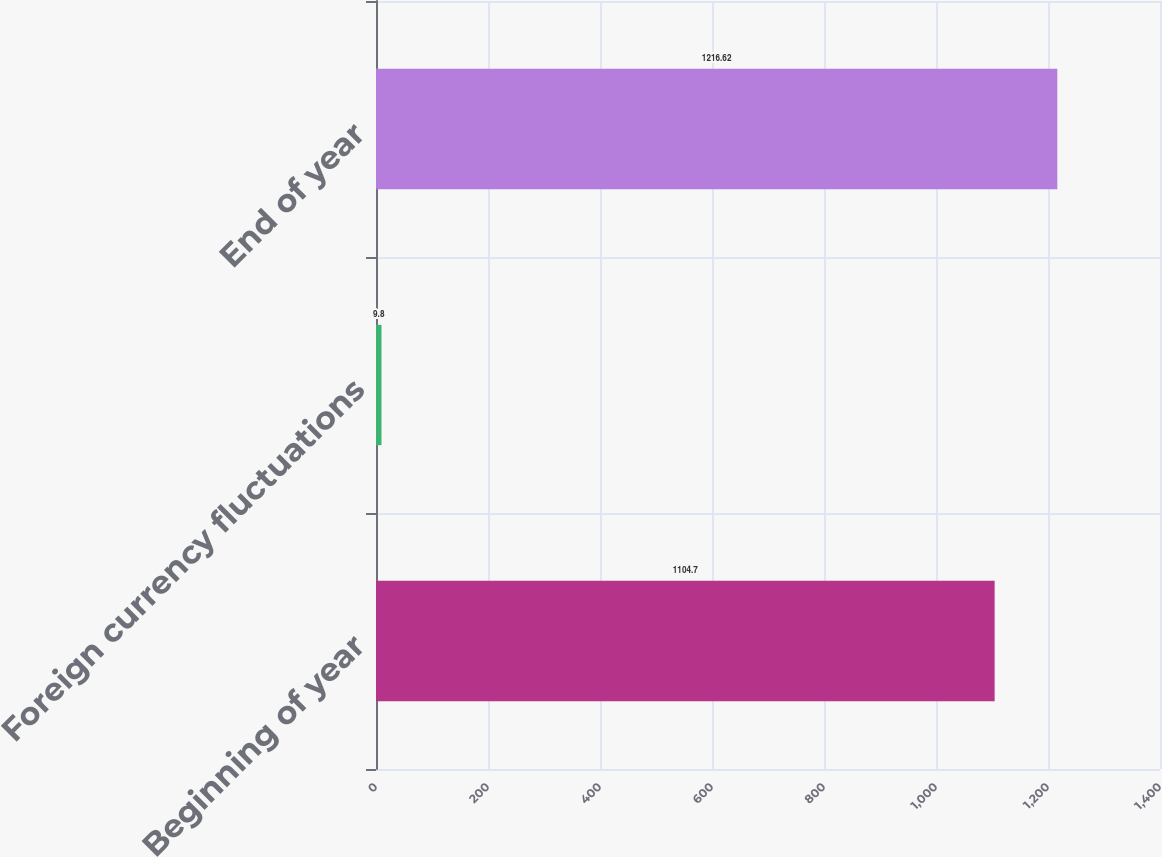Convert chart. <chart><loc_0><loc_0><loc_500><loc_500><bar_chart><fcel>Beginning of year<fcel>Foreign currency fluctuations<fcel>End of year<nl><fcel>1104.7<fcel>9.8<fcel>1216.62<nl></chart> 